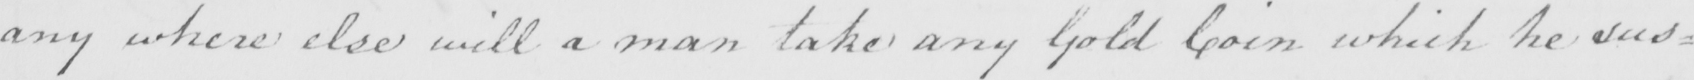What does this handwritten line say? any where else will a man take any Gold coin which he sus= 